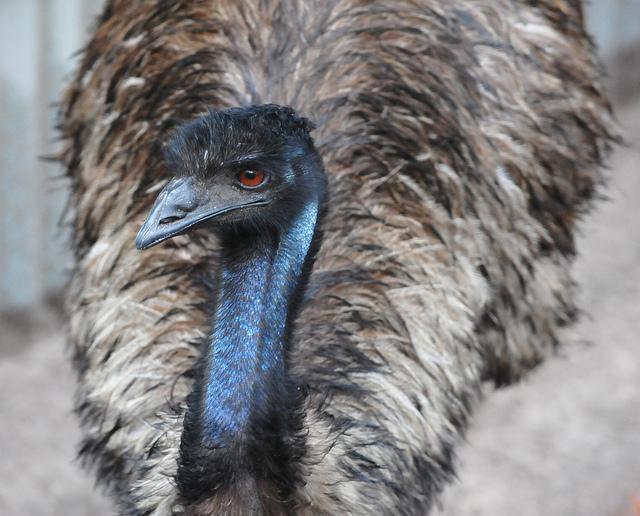Does this bird have a lot of feathers?
Be succinct. Yes. What texture is the birds fir?
Answer briefly. Soft. What kind of bird is this?
Quick response, please. Ostrich. 